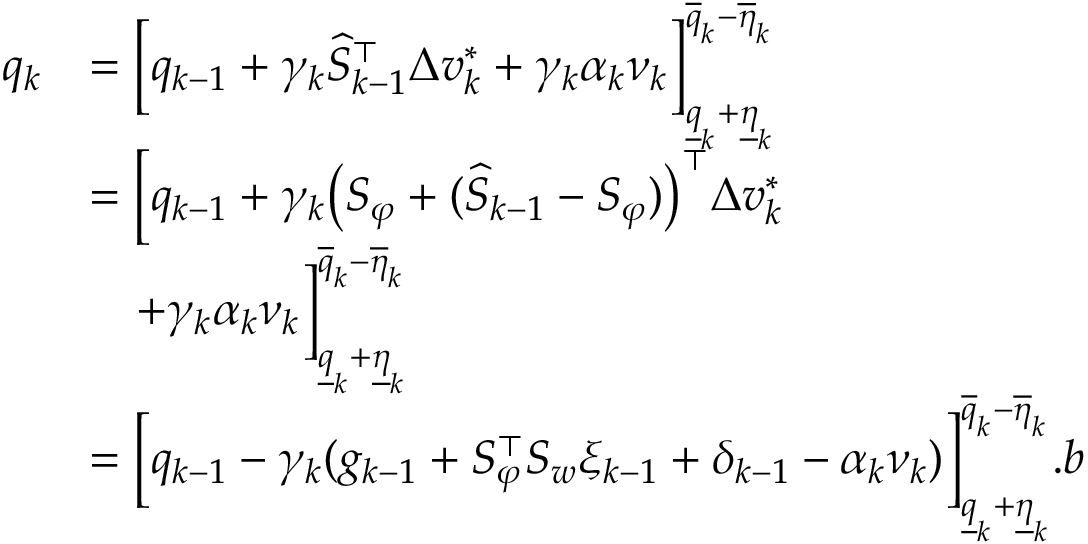<formula> <loc_0><loc_0><loc_500><loc_500>\begin{array} { r l } { q _ { k } } & { = \left [ q _ { k - 1 } + \gamma _ { k } \widehat { S } _ { k - 1 } ^ { \top } \Delta v _ { k } ^ { * } + \gamma _ { k } \alpha _ { k } \nu _ { k } \right ] _ { \underline { q } _ { k } + \underline { \eta } _ { k } } ^ { \overline { q } _ { k } - \overline { \eta } _ { k } } } \\ & { = \left [ q _ { k - 1 } + \gamma _ { k } \left ( S _ { \varphi } + ( \widehat { S } _ { k - 1 } - S _ { \varphi } ) \right ) ^ { \top } \Delta v _ { k } ^ { * } } \\ & { \quad + \gamma _ { k } \alpha _ { k } \nu _ { k } \right ] _ { \underline { q } _ { k } + \underline { \eta } _ { k } } ^ { \overline { q } _ { k } - \overline { \eta } _ { k } } } \\ & { = \left [ q _ { k - 1 } - \gamma _ { k } ( g _ { k - 1 } + S _ { \varphi } ^ { \top } S _ { w } \xi _ { k - 1 } + \delta _ { k - 1 } - \alpha _ { k } \nu _ { k } ) \right ] _ { \underline { q } _ { k } + \underline { \eta } _ { k } } ^ { \overline { q } _ { k } - \overline { \eta } _ { k } } . b } \end{array}</formula> 